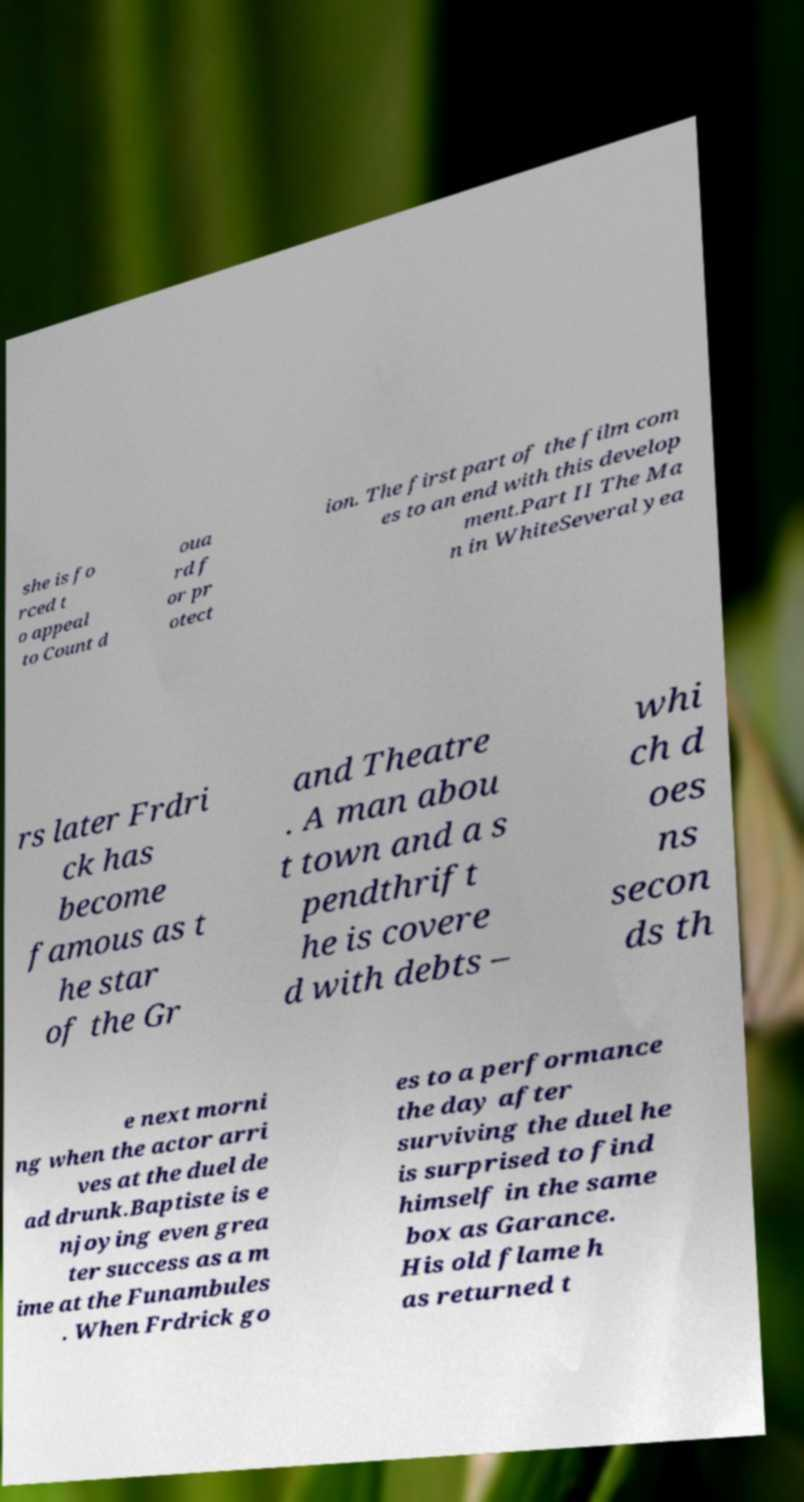Could you assist in decoding the text presented in this image and type it out clearly? she is fo rced t o appeal to Count d oua rd f or pr otect ion. The first part of the film com es to an end with this develop ment.Part II The Ma n in WhiteSeveral yea rs later Frdri ck has become famous as t he star of the Gr and Theatre . A man abou t town and a s pendthrift he is covere d with debts – whi ch d oes ns secon ds th e next morni ng when the actor arri ves at the duel de ad drunk.Baptiste is e njoying even grea ter success as a m ime at the Funambules . When Frdrick go es to a performance the day after surviving the duel he is surprised to find himself in the same box as Garance. His old flame h as returned t 